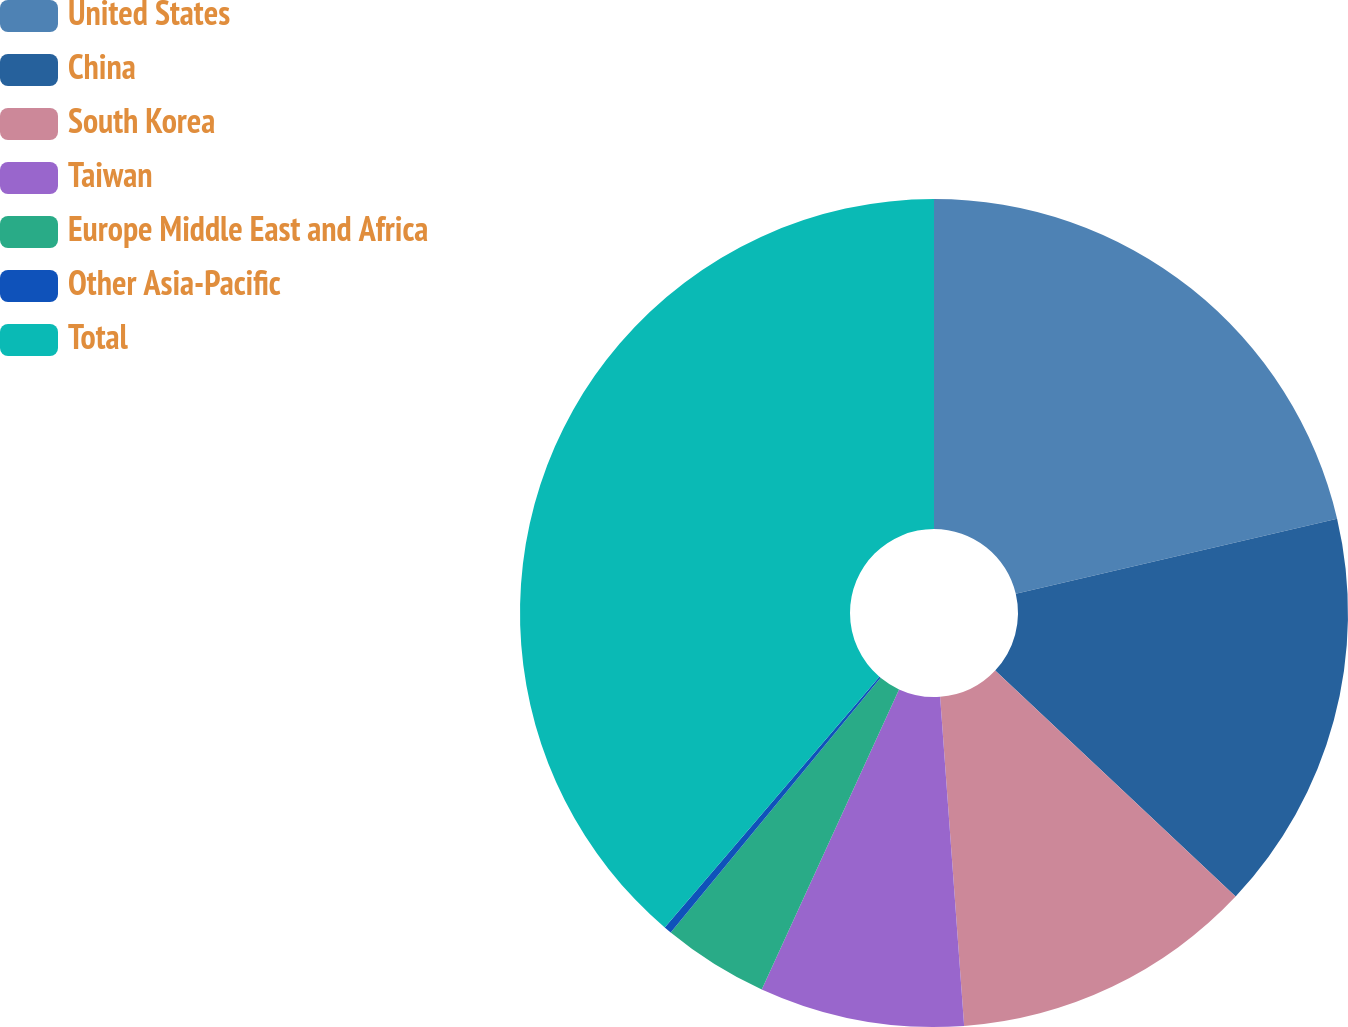Convert chart to OTSL. <chart><loc_0><loc_0><loc_500><loc_500><pie_chart><fcel>United States<fcel>China<fcel>South Korea<fcel>Taiwan<fcel>Europe Middle East and Africa<fcel>Other Asia-Pacific<fcel>Total<nl><fcel>21.34%<fcel>15.67%<fcel>11.83%<fcel>7.99%<fcel>4.14%<fcel>0.3%<fcel>38.73%<nl></chart> 